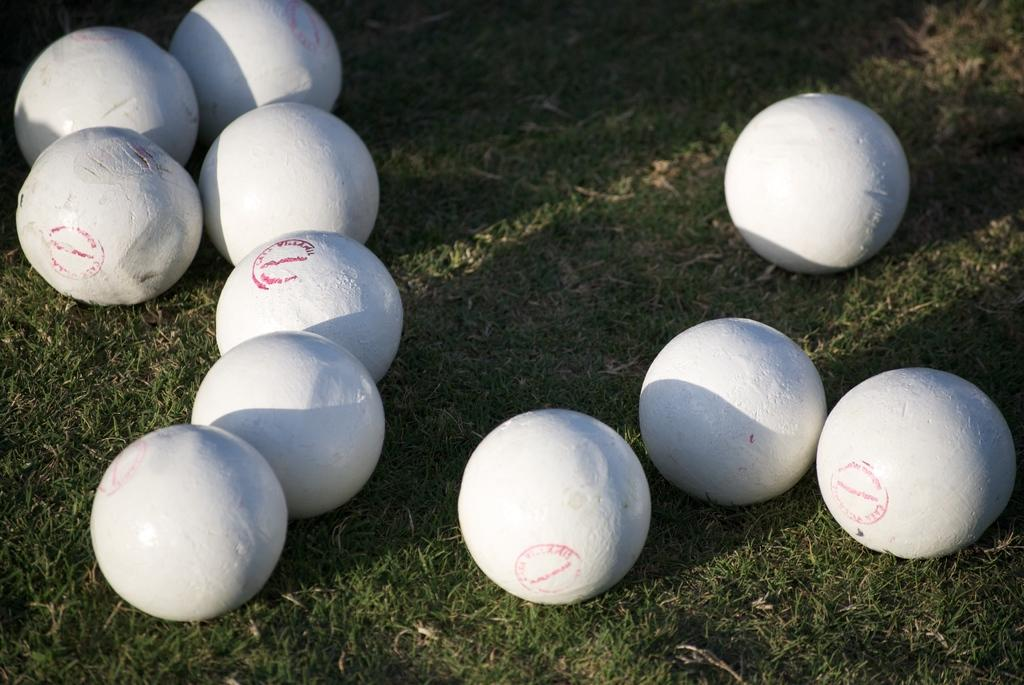What color are the balls in the image? The balls in the image are white. What additional feature can be seen on the balls? The balls have red stamps. Where are the balls located? The balls are placed on the grass. How much payment is required to start using the kettle in the image? There is no kettle present in the image, so it is not possible to determine any payment or starting requirements. 